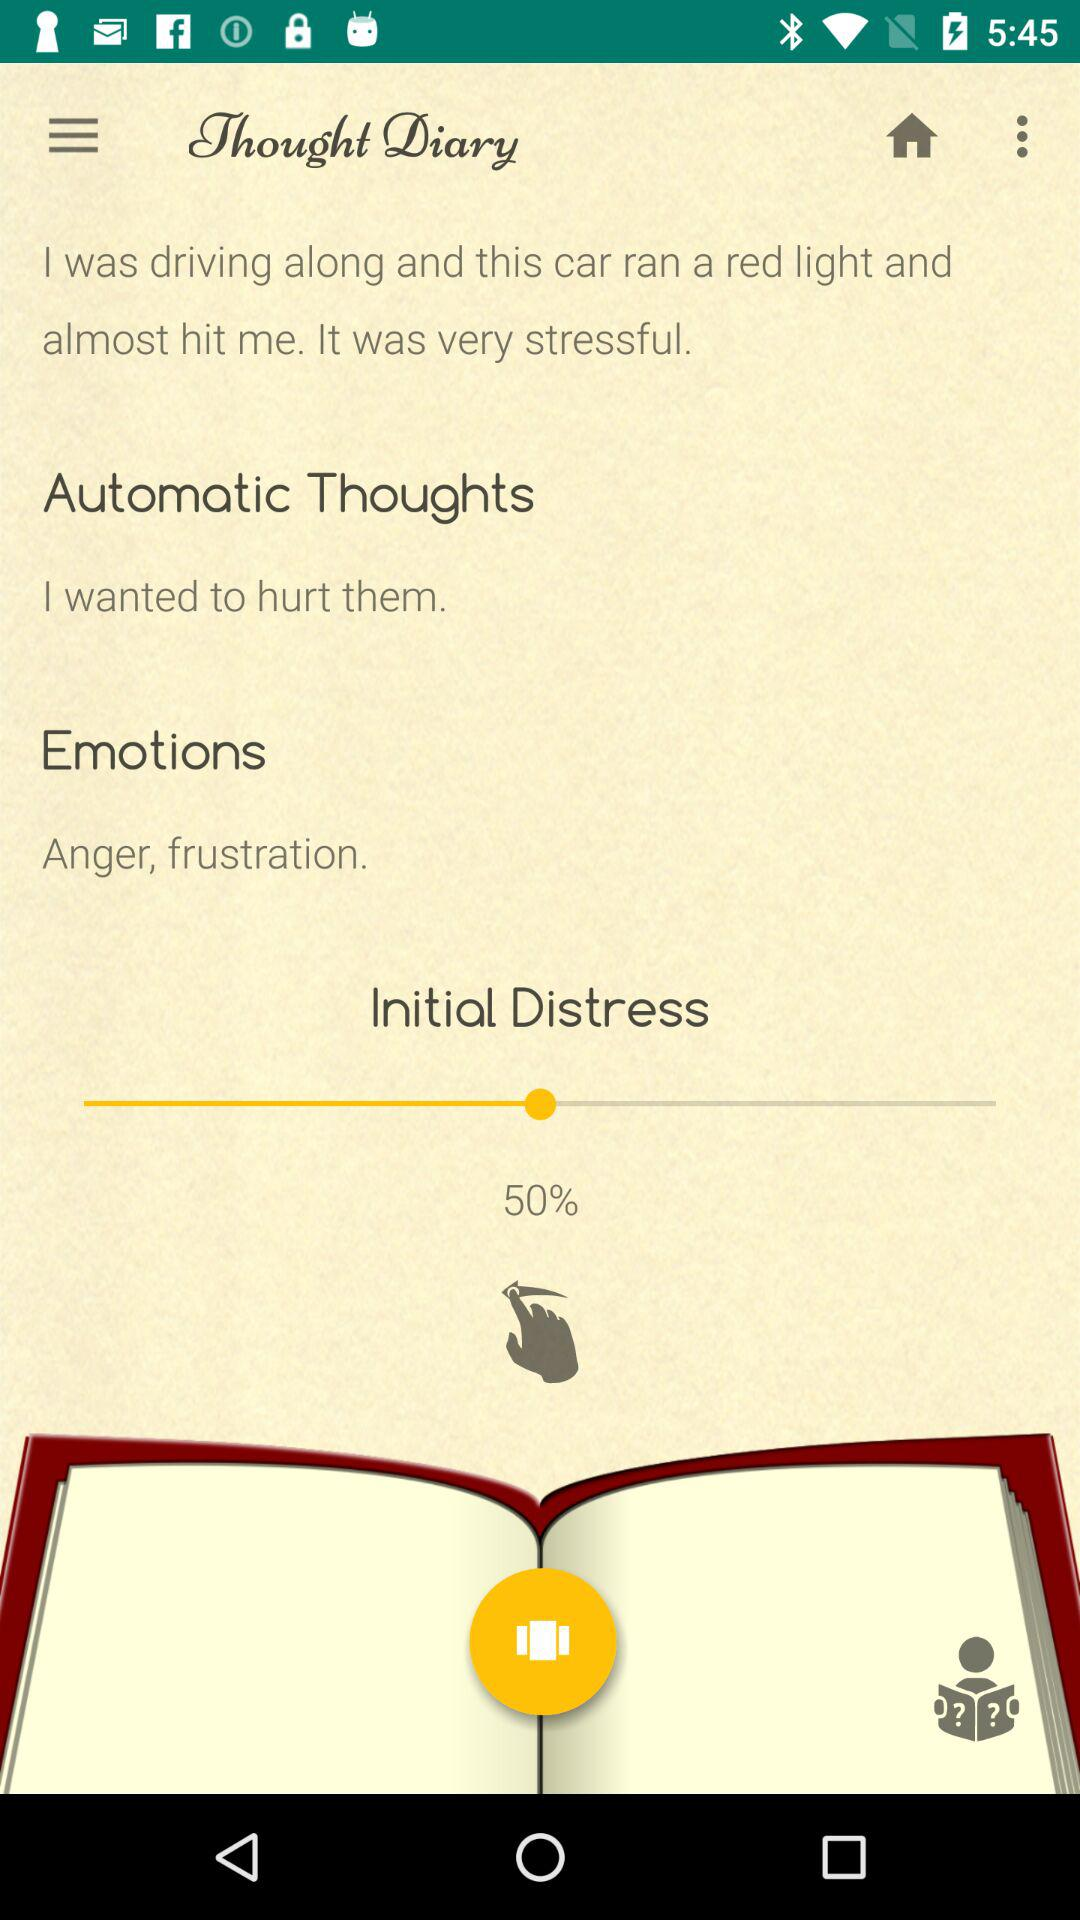How many emotion entries are there?
Answer the question using a single word or phrase. 2 